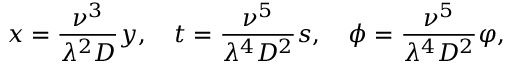Convert formula to latex. <formula><loc_0><loc_0><loc_500><loc_500>x = \frac { \nu ^ { 3 } } { \lambda ^ { 2 } D } y , \quad t = \frac { \nu ^ { 5 } } { \lambda ^ { 4 } D ^ { 2 } } s , \quad p h i = \frac { \nu ^ { 5 } } { \lambda ^ { 4 } D ^ { 2 } } \varphi ,</formula> 